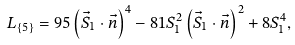Convert formula to latex. <formula><loc_0><loc_0><loc_500><loc_500>L _ { \{ 5 \} } = 9 5 \left ( \vec { S } _ { 1 } \cdot \vec { n } \right ) ^ { 4 } - 8 1 S _ { 1 } ^ { 2 } \left ( \vec { S } _ { 1 } \cdot \vec { n } \right ) ^ { 2 } + 8 S _ { 1 } ^ { 4 } ,</formula> 